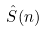<formula> <loc_0><loc_0><loc_500><loc_500>\hat { S } ( n )</formula> 